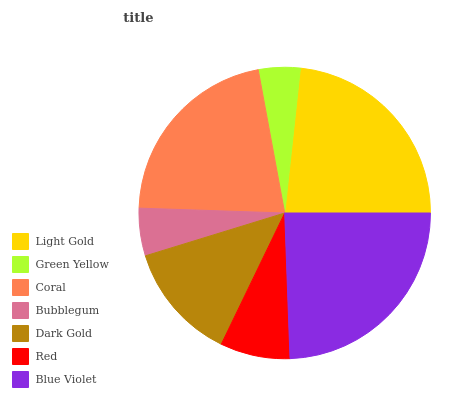Is Green Yellow the minimum?
Answer yes or no. Yes. Is Blue Violet the maximum?
Answer yes or no. Yes. Is Coral the minimum?
Answer yes or no. No. Is Coral the maximum?
Answer yes or no. No. Is Coral greater than Green Yellow?
Answer yes or no. Yes. Is Green Yellow less than Coral?
Answer yes or no. Yes. Is Green Yellow greater than Coral?
Answer yes or no. No. Is Coral less than Green Yellow?
Answer yes or no. No. Is Dark Gold the high median?
Answer yes or no. Yes. Is Dark Gold the low median?
Answer yes or no. Yes. Is Red the high median?
Answer yes or no. No. Is Blue Violet the low median?
Answer yes or no. No. 